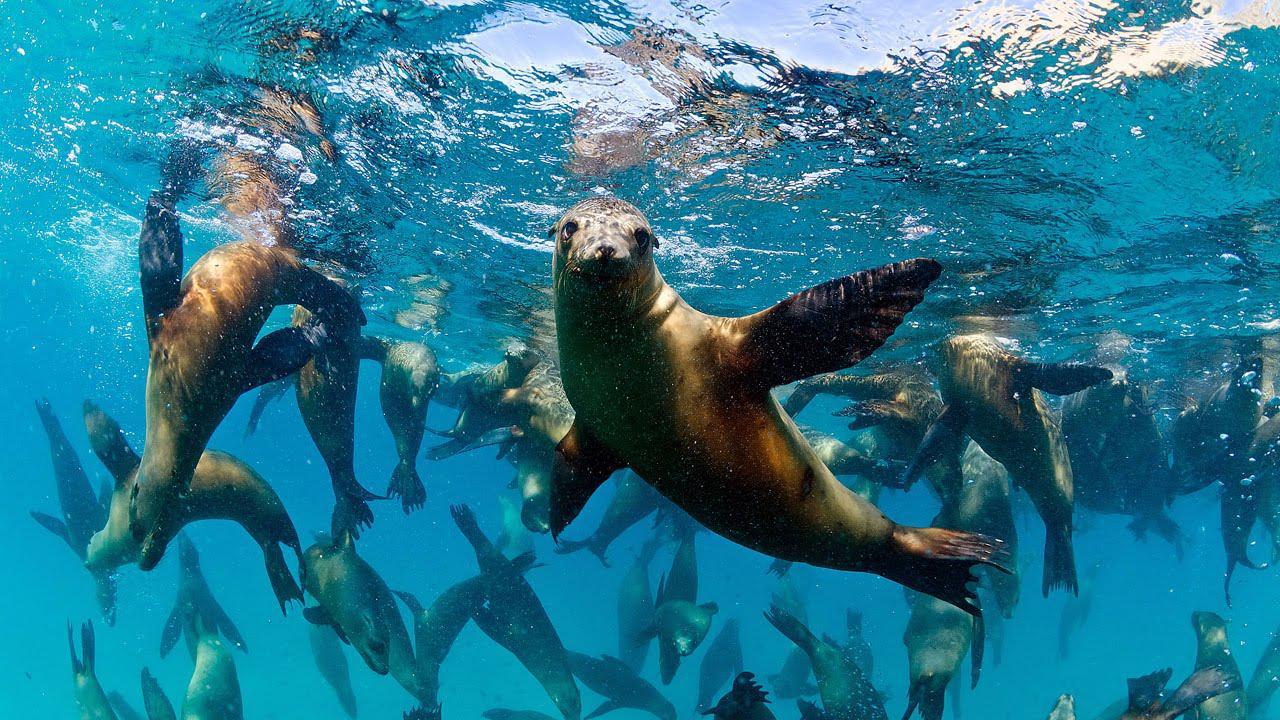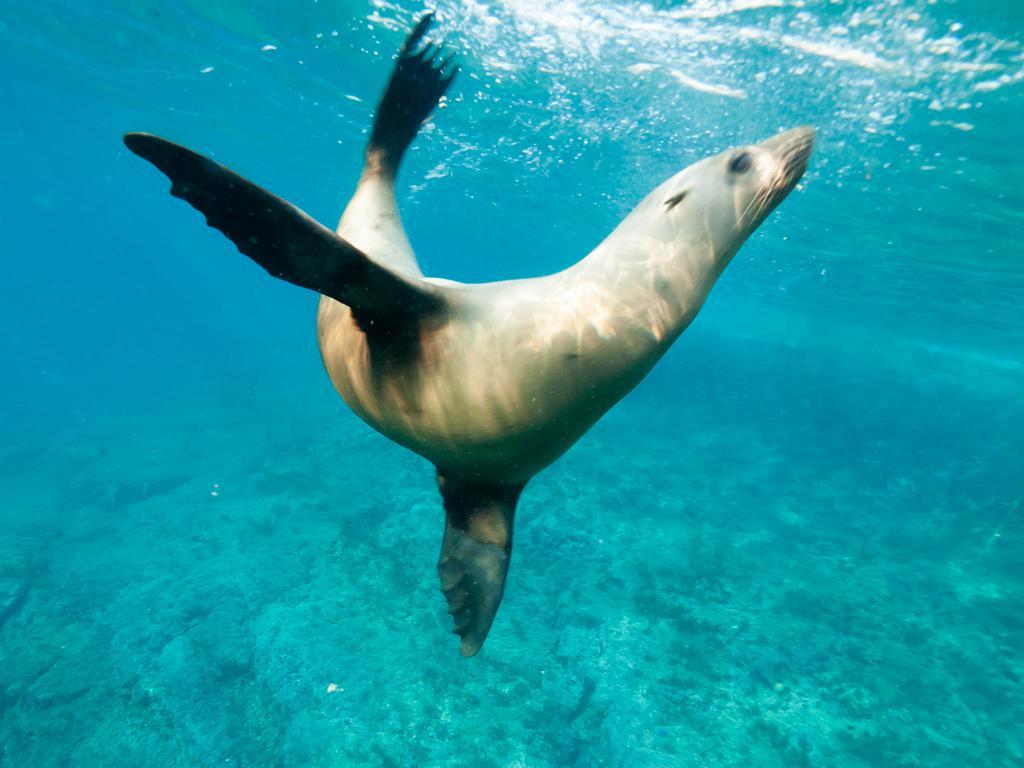The first image is the image on the left, the second image is the image on the right. Evaluate the accuracy of this statement regarding the images: "We have two seals here, swimming.". Is it true? Answer yes or no. No. The first image is the image on the left, the second image is the image on the right. Considering the images on both sides, is "there are two animals total" valid? Answer yes or no. No. 